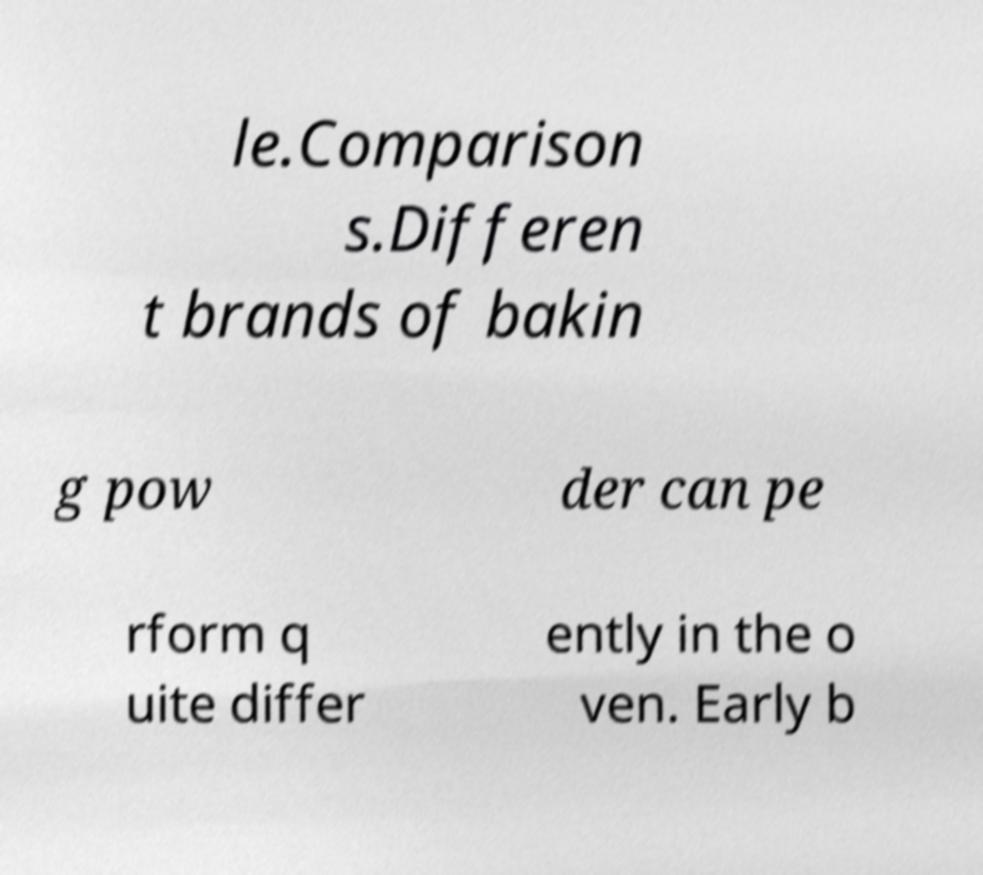Can you accurately transcribe the text from the provided image for me? le.Comparison s.Differen t brands of bakin g pow der can pe rform q uite differ ently in the o ven. Early b 